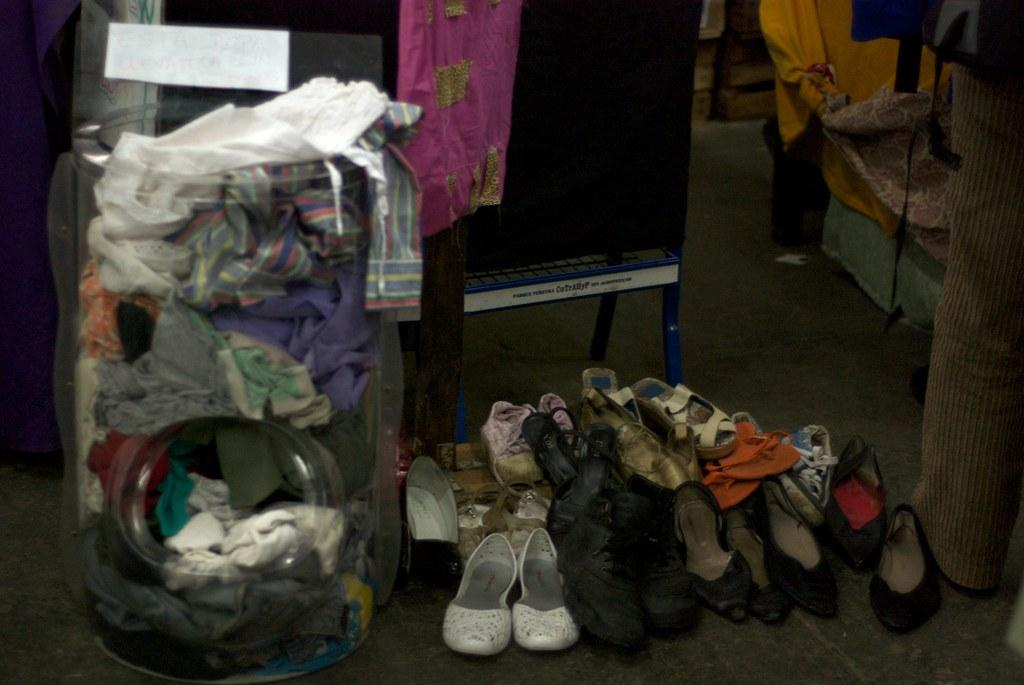What is the main object in the image? There is a tub in the image. What is on top of the tub? Clothes are on the tub. What type of footwear can be seen on the floor? There are shoes visible on the floor. What piece of furniture is visible on the floor? A chair is visible on the floor. What type of stone is used to build the organization's headquarters in the image? There is no organization or headquarters present in the image, and therefore no stone can be identified. 